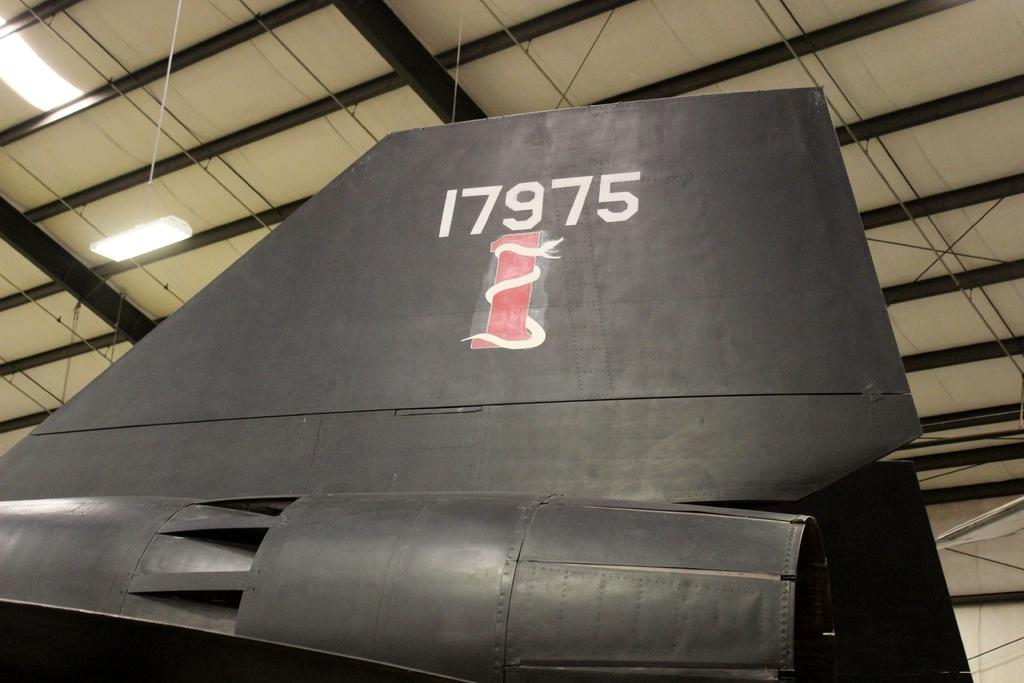<image>
Write a terse but informative summary of the picture. The tail section of a black aircraft with the number 17975 painted above a snake. 